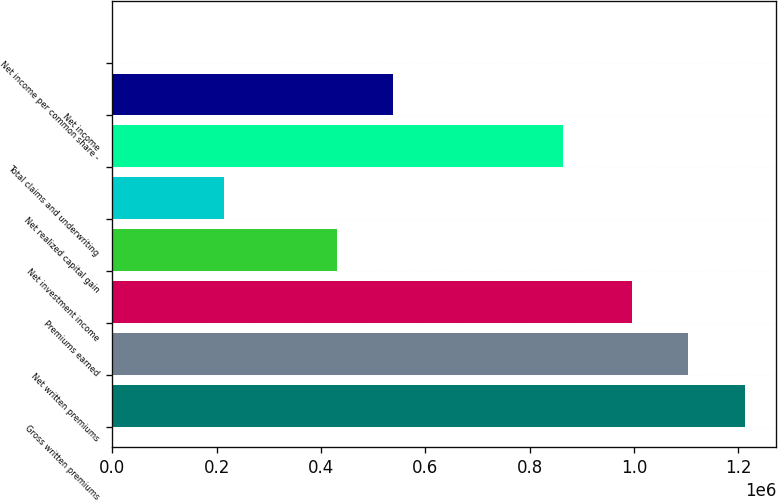Convert chart. <chart><loc_0><loc_0><loc_500><loc_500><bar_chart><fcel>Gross written premiums<fcel>Net written premiums<fcel>Premiums earned<fcel>Net investment income<fcel>Net realized capital gain<fcel>Total claims and underwriting<fcel>Net income<fcel>Net income per common share -<nl><fcel>1.21199e+06<fcel>1.10452e+06<fcel>997055<fcel>429872<fcel>214938<fcel>863691<fcel>537338<fcel>3.9<nl></chart> 